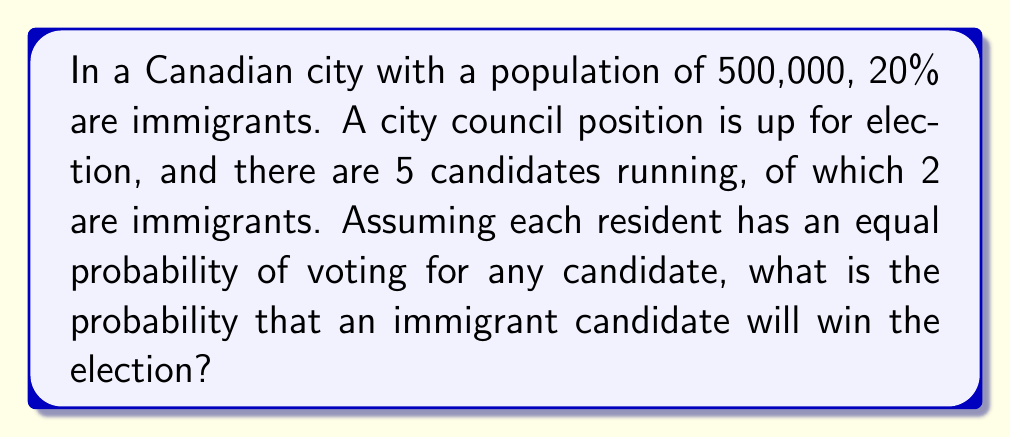Teach me how to tackle this problem. Let's approach this step-by-step:

1) First, we need to understand that the probability of an immigrant winning is equal to the sum of the probabilities of each immigrant candidate winning.

2) For any candidate to win, they need to receive more votes than any other candidate. In a scenario where each resident has an equal probability of voting for any candidate, the probability of a specific candidate winning is $\frac{1}{5}$, as there are 5 candidates in total.

3) Since there are 2 immigrant candidates, and each has a $\frac{1}{5}$ chance of winning, we can calculate the total probability of an immigrant winning as:

   $$P(\text{immigrant wins}) = \frac{1}{5} + \frac{1}{5} = \frac{2}{5} = 0.4$$

4) It's important to note that this probability is independent of the proportion of immigrants in the population. The fact that 20% of the city's population are immigrants doesn't affect the probability in this case, because we assumed each resident has an equal probability of voting for any candidate.

5) However, if we were to consider potential voting biases or preferences based on immigrant status, the calculation would become more complex and would need to take into account the 20% immigrant population.
Answer: The probability that an immigrant candidate will win the election is $\frac{2}{5}$ or 0.4 or 40%. 